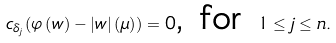<formula> <loc_0><loc_0><loc_500><loc_500>c _ { \delta _ { j } } ( \varphi \left ( w \right ) - \left | w \right | \left ( \mu \right ) ) = 0 \text {, for } 1 \leq j \leq n .</formula> 